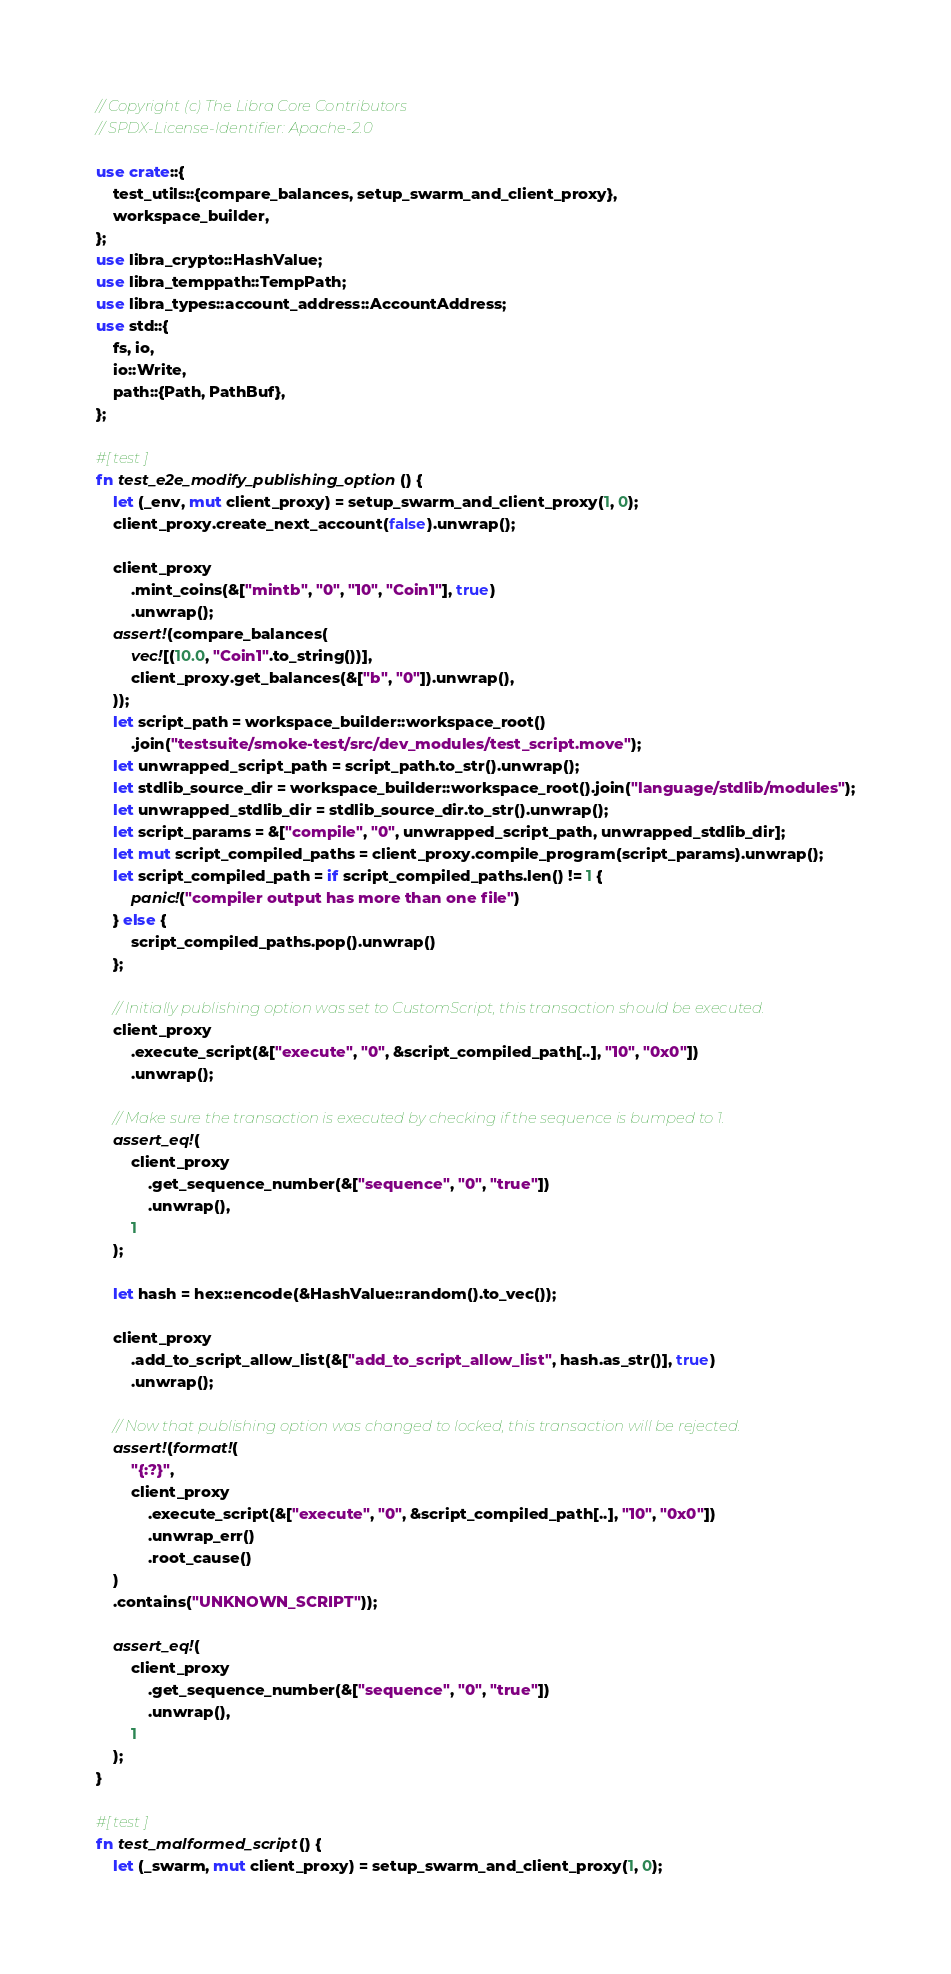<code> <loc_0><loc_0><loc_500><loc_500><_Rust_>// Copyright (c) The Libra Core Contributors
// SPDX-License-Identifier: Apache-2.0

use crate::{
    test_utils::{compare_balances, setup_swarm_and_client_proxy},
    workspace_builder,
};
use libra_crypto::HashValue;
use libra_temppath::TempPath;
use libra_types::account_address::AccountAddress;
use std::{
    fs, io,
    io::Write,
    path::{Path, PathBuf},
};

#[test]
fn test_e2e_modify_publishing_option() {
    let (_env, mut client_proxy) = setup_swarm_and_client_proxy(1, 0);
    client_proxy.create_next_account(false).unwrap();

    client_proxy
        .mint_coins(&["mintb", "0", "10", "Coin1"], true)
        .unwrap();
    assert!(compare_balances(
        vec![(10.0, "Coin1".to_string())],
        client_proxy.get_balances(&["b", "0"]).unwrap(),
    ));
    let script_path = workspace_builder::workspace_root()
        .join("testsuite/smoke-test/src/dev_modules/test_script.move");
    let unwrapped_script_path = script_path.to_str().unwrap();
    let stdlib_source_dir = workspace_builder::workspace_root().join("language/stdlib/modules");
    let unwrapped_stdlib_dir = stdlib_source_dir.to_str().unwrap();
    let script_params = &["compile", "0", unwrapped_script_path, unwrapped_stdlib_dir];
    let mut script_compiled_paths = client_proxy.compile_program(script_params).unwrap();
    let script_compiled_path = if script_compiled_paths.len() != 1 {
        panic!("compiler output has more than one file")
    } else {
        script_compiled_paths.pop().unwrap()
    };

    // Initially publishing option was set to CustomScript, this transaction should be executed.
    client_proxy
        .execute_script(&["execute", "0", &script_compiled_path[..], "10", "0x0"])
        .unwrap();

    // Make sure the transaction is executed by checking if the sequence is bumped to 1.
    assert_eq!(
        client_proxy
            .get_sequence_number(&["sequence", "0", "true"])
            .unwrap(),
        1
    );

    let hash = hex::encode(&HashValue::random().to_vec());

    client_proxy
        .add_to_script_allow_list(&["add_to_script_allow_list", hash.as_str()], true)
        .unwrap();

    // Now that publishing option was changed to locked, this transaction will be rejected.
    assert!(format!(
        "{:?}",
        client_proxy
            .execute_script(&["execute", "0", &script_compiled_path[..], "10", "0x0"])
            .unwrap_err()
            .root_cause()
    )
    .contains("UNKNOWN_SCRIPT"));

    assert_eq!(
        client_proxy
            .get_sequence_number(&["sequence", "0", "true"])
            .unwrap(),
        1
    );
}

#[test]
fn test_malformed_script() {
    let (_swarm, mut client_proxy) = setup_swarm_and_client_proxy(1, 0);</code> 